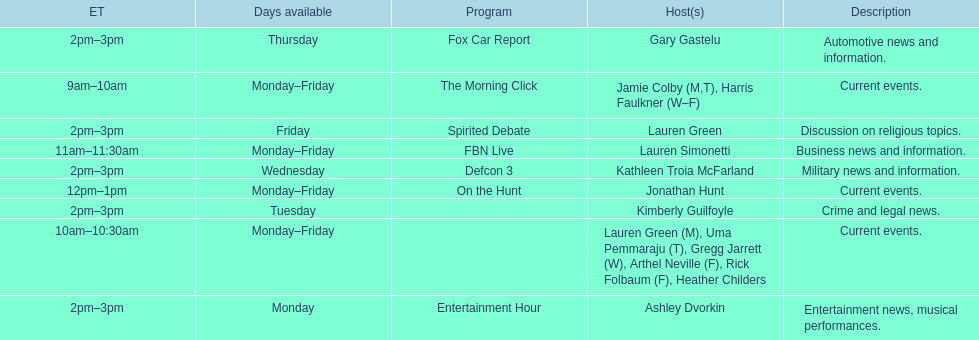What is the first show to play on monday mornings? The Morning Click. 